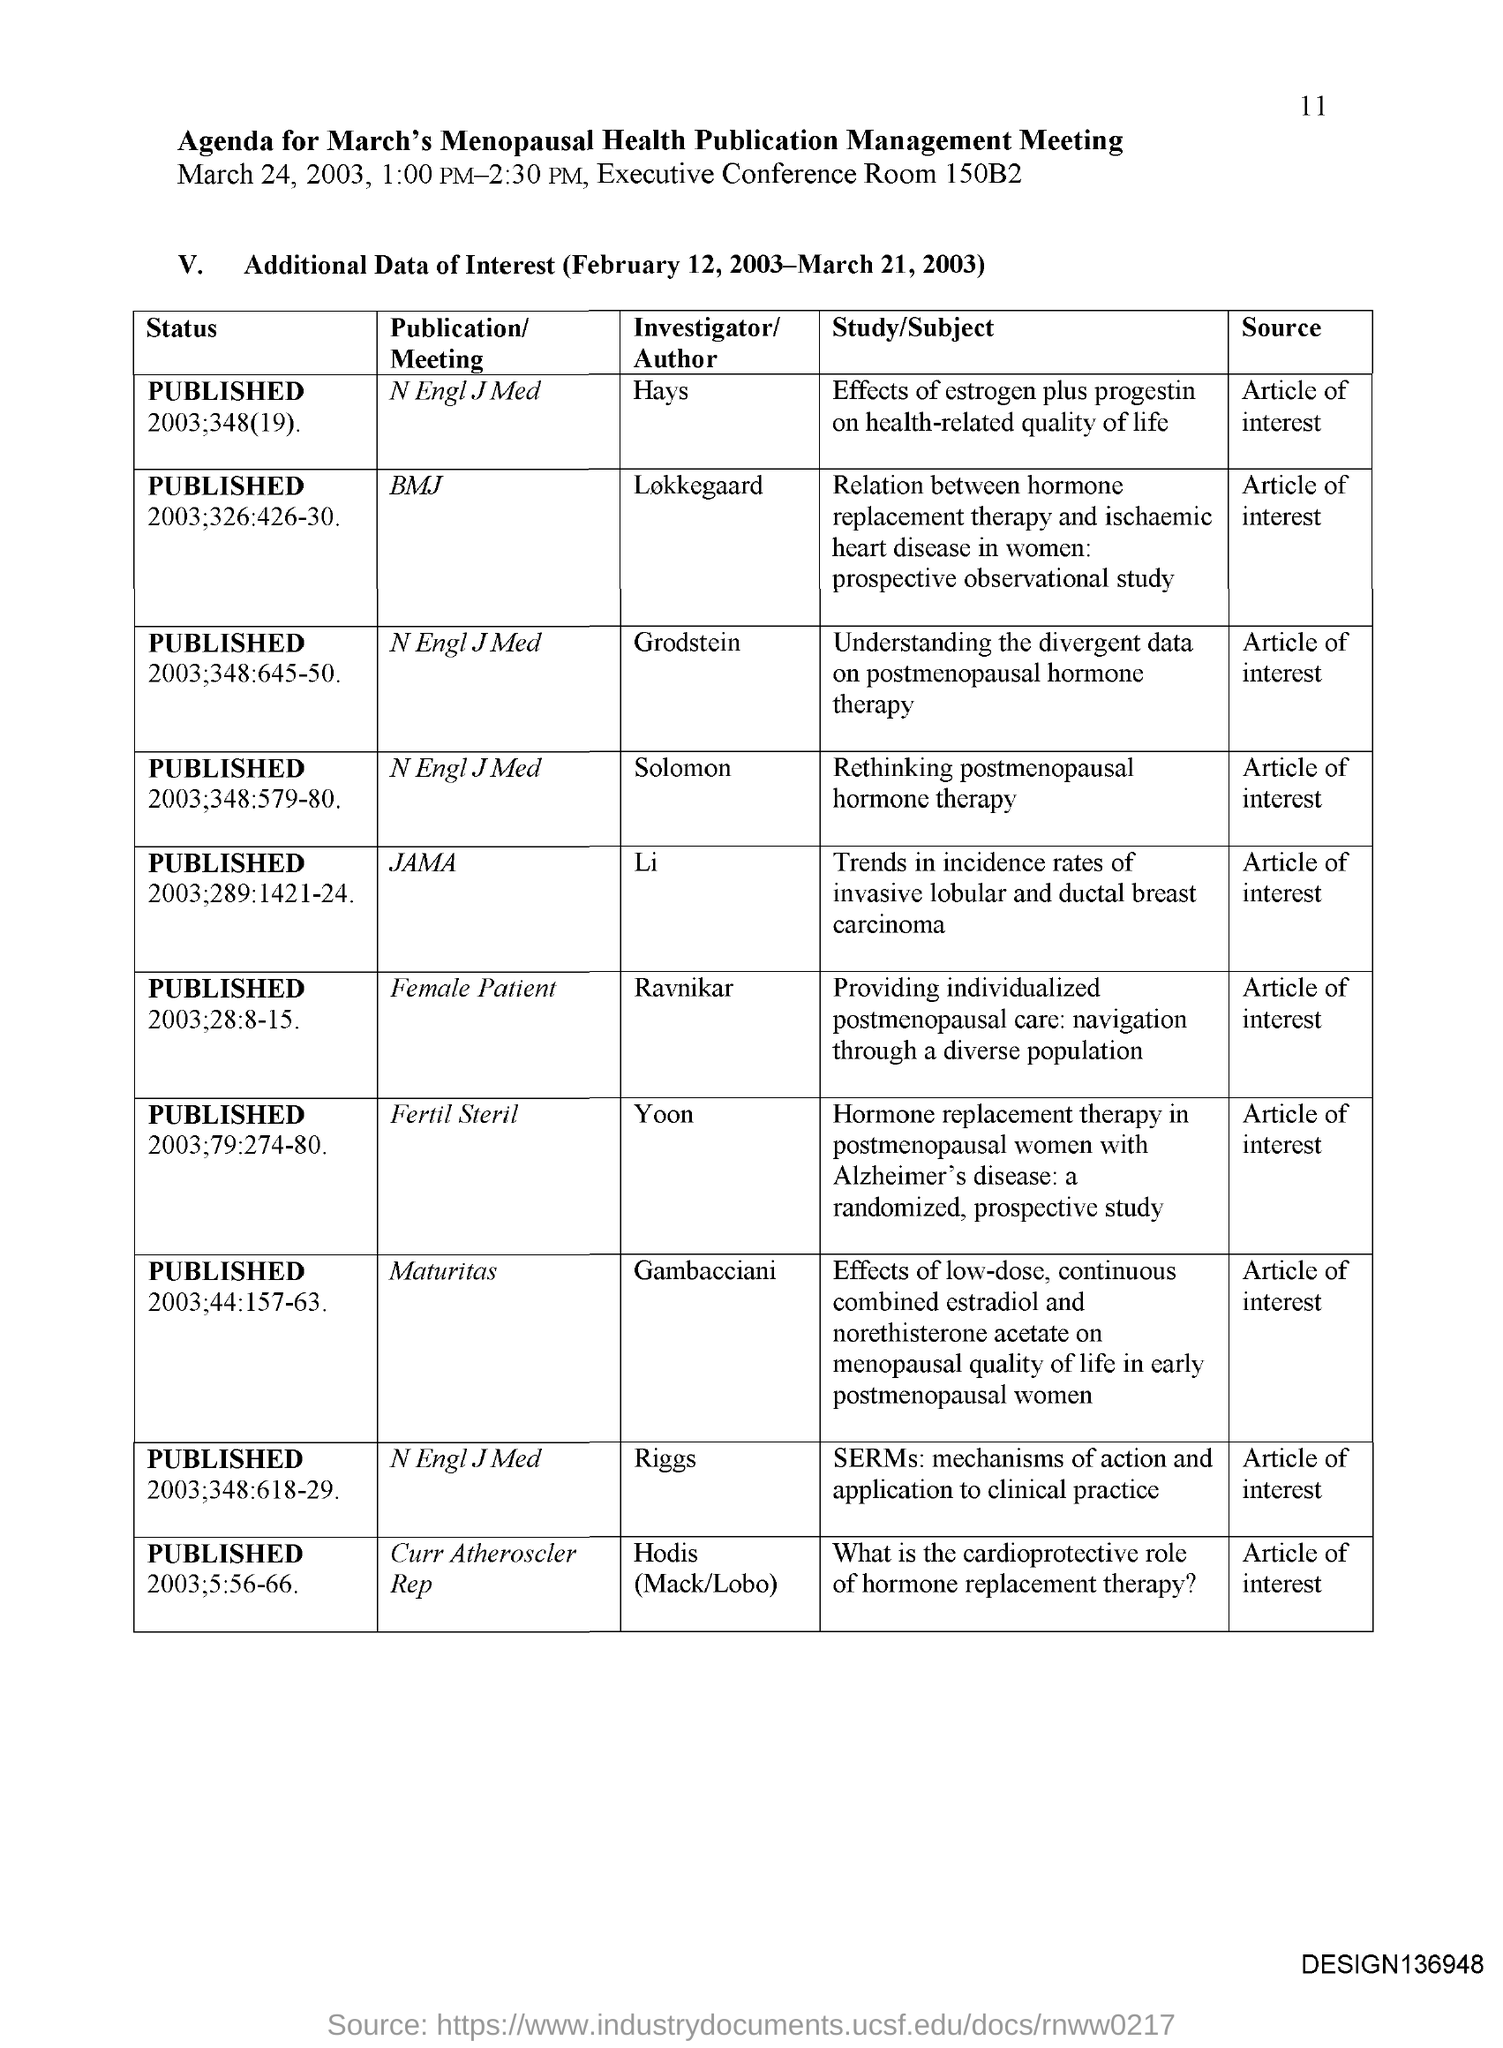Point out several critical features in this image. The investigator for the publication in JAMA is [Name]. The investigator for the publication in the BMJ is Lars Løkkegaard. The investigator for the publication "Fertil Steril" is Yoon. 